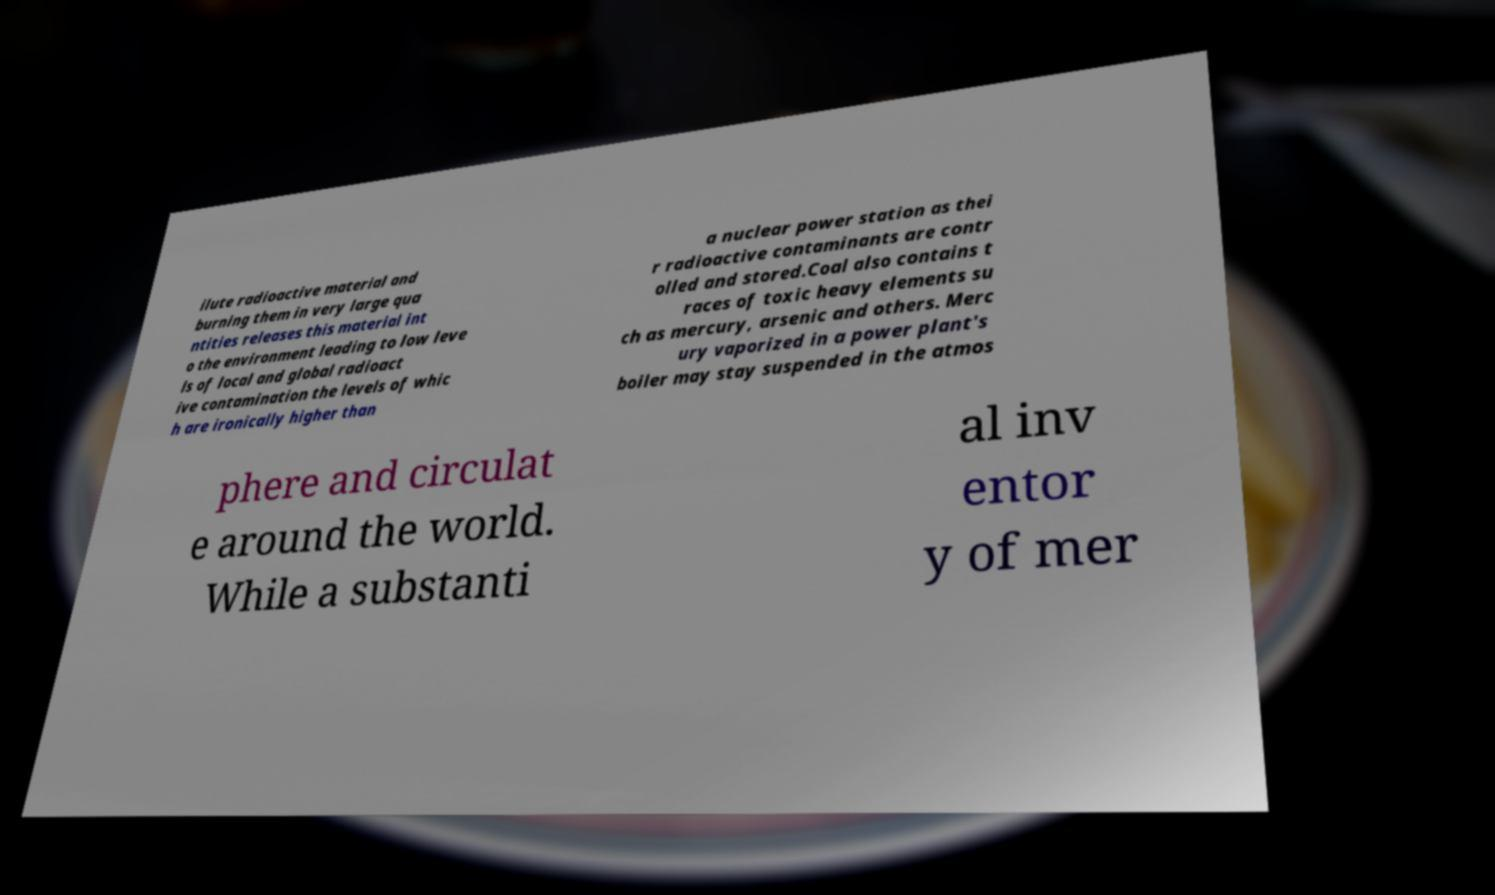What messages or text are displayed in this image? I need them in a readable, typed format. ilute radioactive material and burning them in very large qua ntities releases this material int o the environment leading to low leve ls of local and global radioact ive contamination the levels of whic h are ironically higher than a nuclear power station as thei r radioactive contaminants are contr olled and stored.Coal also contains t races of toxic heavy elements su ch as mercury, arsenic and others. Merc ury vaporized in a power plant's boiler may stay suspended in the atmos phere and circulat e around the world. While a substanti al inv entor y of mer 